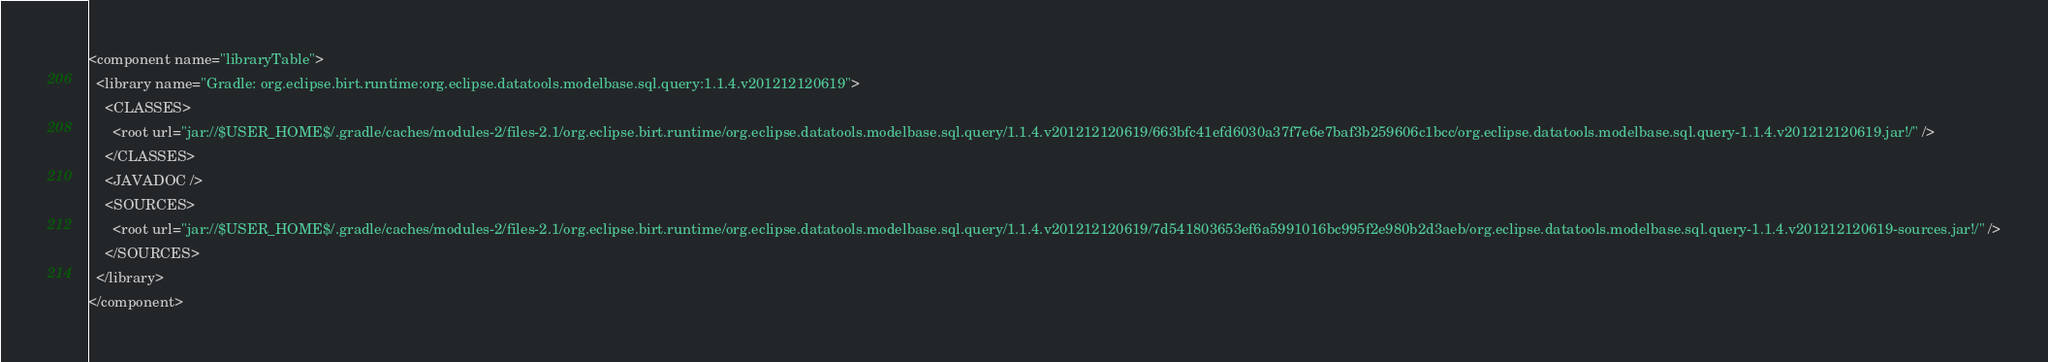Convert code to text. <code><loc_0><loc_0><loc_500><loc_500><_XML_><component name="libraryTable">
  <library name="Gradle: org.eclipse.birt.runtime:org.eclipse.datatools.modelbase.sql.query:1.1.4.v201212120619">
    <CLASSES>
      <root url="jar://$USER_HOME$/.gradle/caches/modules-2/files-2.1/org.eclipse.birt.runtime/org.eclipse.datatools.modelbase.sql.query/1.1.4.v201212120619/663bfc41efd6030a37f7e6e7baf3b259606c1bcc/org.eclipse.datatools.modelbase.sql.query-1.1.4.v201212120619.jar!/" />
    </CLASSES>
    <JAVADOC />
    <SOURCES>
      <root url="jar://$USER_HOME$/.gradle/caches/modules-2/files-2.1/org.eclipse.birt.runtime/org.eclipse.datatools.modelbase.sql.query/1.1.4.v201212120619/7d541803653ef6a5991016bc995f2e980b2d3aeb/org.eclipse.datatools.modelbase.sql.query-1.1.4.v201212120619-sources.jar!/" />
    </SOURCES>
  </library>
</component></code> 